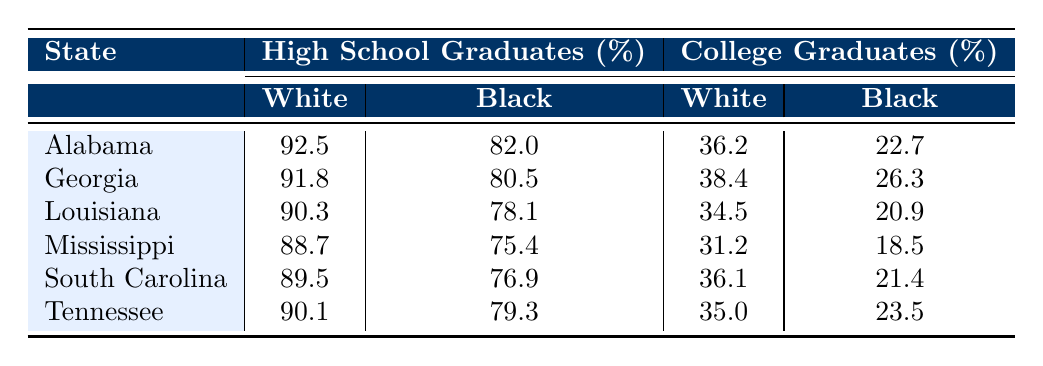What is the percentage of white high school graduates in Louisiana? Referring to the table for Louisiana, the value listed under white high school graduates is 90.3%.
Answer: 90.3 Which state has the highest percentage of black college graduates? By examining the black college graduates column, the state with the highest percentage is Georgia at 26.3%.
Answer: Georgia What is the difference in the percentage of white and black high school graduates in Alabama? For Alabama, the white high school graduates percentage is 92.5% and the black high school graduates percentage is 82.0%. The difference is 92.5 - 82.0 = 10.5%.
Answer: 10.5 Is the percentage of black high school graduates in Mississippi higher than that in South Carolina? The percentage of black high school graduates in Mississippi is 75.4% and in South Carolina is 76.9%. Since 75.4% is less than 76.9%, the statement is false.
Answer: No What is the average percentage of white college graduates across all states? To find the average, sum the percentages for white college graduates across all states: (36.2 + 38.4 + 34.5 + 31.2 + 36.1 + 35.0) = 211.4. Then, divide by the number of states (6): 211.4 / 6 = 35.23%.
Answer: 35.23 What percentage of high school graduates are white in Tennessee? In the table, for Tennessee, the percentage of white high school graduates is listed as 90.1%.
Answer: 90.1 Which state shows the smallest percentage of black college graduates? Looking at the black college graduates column, Mississippi shows the smallest percentage at 18.5%.
Answer: Mississippi What is the combined percentage of white and black high school graduates in Georgia? For Georgia, the percentage of white high school graduates is 91.8% and black high school graduates is 80.5%. Their combined percentage is 91.8 + 80.5 = 172.3%.
Answer: 172.3 